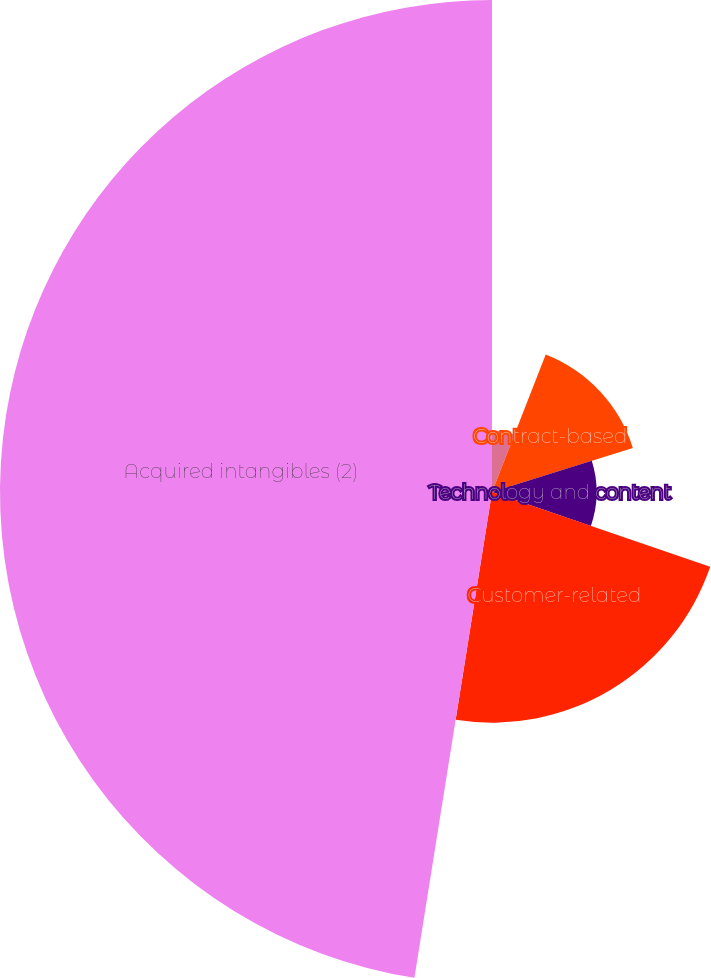<chart> <loc_0><loc_0><loc_500><loc_500><pie_chart><fcel>Marketing-related<fcel>Contract-based<fcel>Technology and content<fcel>Customer-related<fcel>Acquired intangibles (2)<nl><fcel>5.93%<fcel>14.24%<fcel>10.09%<fcel>22.26%<fcel>47.48%<nl></chart> 